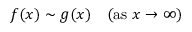<formula> <loc_0><loc_0><loc_500><loc_500>f ( x ) \sim g ( x ) \quad ( { a s } x \to \infty )</formula> 